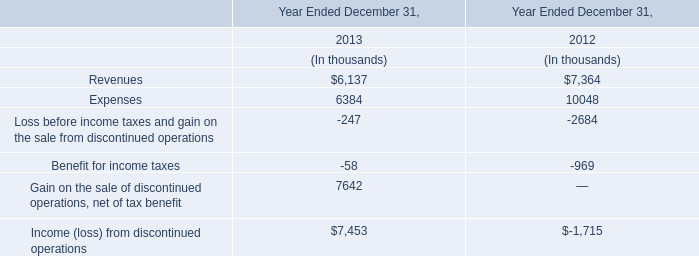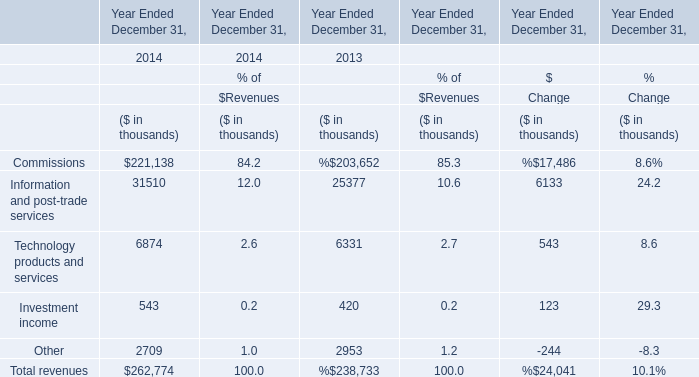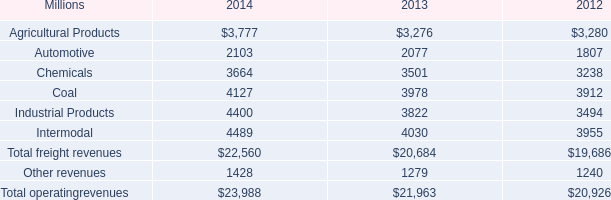If Investment income develops with the same increasing rate in 2014 Ended December 31, what will it reach in 2015 Ended December 31? (in thousand) 
Computations: (543 * (1 + ((543 - 420) / 420)))
Answer: 702.02143. 